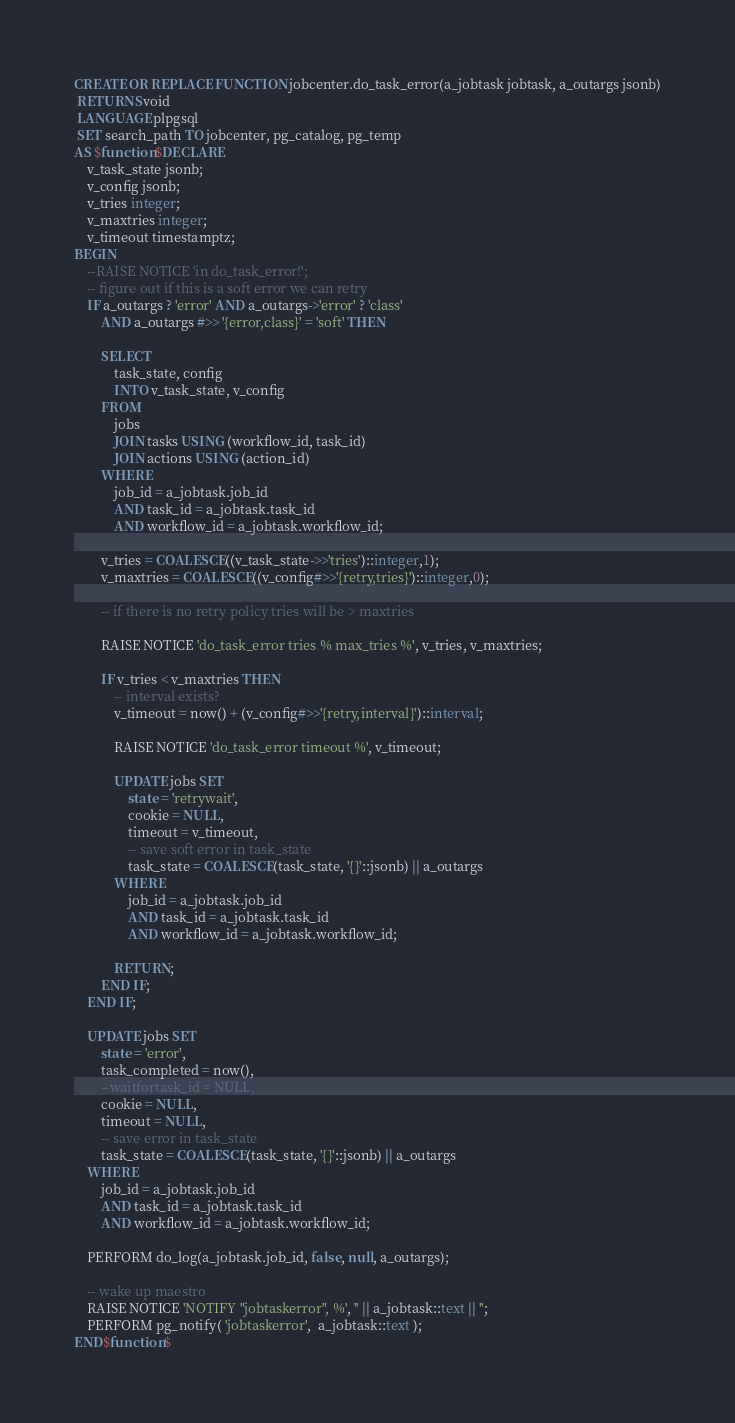<code> <loc_0><loc_0><loc_500><loc_500><_SQL_>CREATE OR REPLACE FUNCTION jobcenter.do_task_error(a_jobtask jobtask, a_outargs jsonb)
 RETURNS void
 LANGUAGE plpgsql
 SET search_path TO jobcenter, pg_catalog, pg_temp
AS $function$DECLARE
	v_task_state jsonb;
	v_config jsonb;
	v_tries integer;
	v_maxtries integer;
	v_timeout timestamptz;
BEGIN
	--RAISE NOTICE 'in do_task_error!';
	-- figure out if this is a soft error we can retry
	IF a_outargs ? 'error' AND a_outargs->'error' ? 'class'
		AND a_outargs #>> '{error,class}' = 'soft' THEN

		SELECT
			task_state, config
			INTO v_task_state, v_config
		FROM
			jobs
			JOIN tasks USING (workflow_id, task_id)
			JOIN actions USING (action_id)
		WHERE
			job_id = a_jobtask.job_id
			AND task_id = a_jobtask.task_id
			AND workflow_id = a_jobtask.workflow_id;

		v_tries = COALESCE((v_task_state->>'tries')::integer,1);
		v_maxtries = COALESCE((v_config#>>'{retry,tries}')::integer,0);

		-- if there is no retry policy tries will be > maxtries

		RAISE NOTICE 'do_task_error tries % max_tries %', v_tries, v_maxtries;

		IF v_tries < v_maxtries THEN
			-- interval exists?
			v_timeout = now() + (v_config#>>'{retry,interval}')::interval;

			RAISE NOTICE 'do_task_error timeout %', v_timeout;

			UPDATE jobs SET
				state = 'retrywait',
				cookie = NULL,
				timeout = v_timeout,
				-- save soft error in task_state
				task_state = COALESCE(task_state, '{}'::jsonb) || a_outargs
			WHERE
				job_id = a_jobtask.job_id
				AND task_id = a_jobtask.task_id
				AND workflow_id = a_jobtask.workflow_id;

			RETURN;
		END IF;
	END IF;

	UPDATE jobs SET
		state = 'error',
		task_completed = now(),
		--waitfortask_id = NULL,
		cookie = NULL,
		timeout = NULL,
		-- save error in task_state
		task_state = COALESCE(task_state, '{}'::jsonb) || a_outargs
	WHERE
		job_id = a_jobtask.job_id
		AND task_id = a_jobtask.task_id
		AND workflow_id = a_jobtask.workflow_id;
	
	PERFORM do_log(a_jobtask.job_id, false, null, a_outargs);

	-- wake up maestro
	RAISE NOTICE 'NOTIFY "jobtaskerror", %', '' || a_jobtask::text || '';
	PERFORM pg_notify( 'jobtaskerror',  a_jobtask::text );
END$function$
</code> 